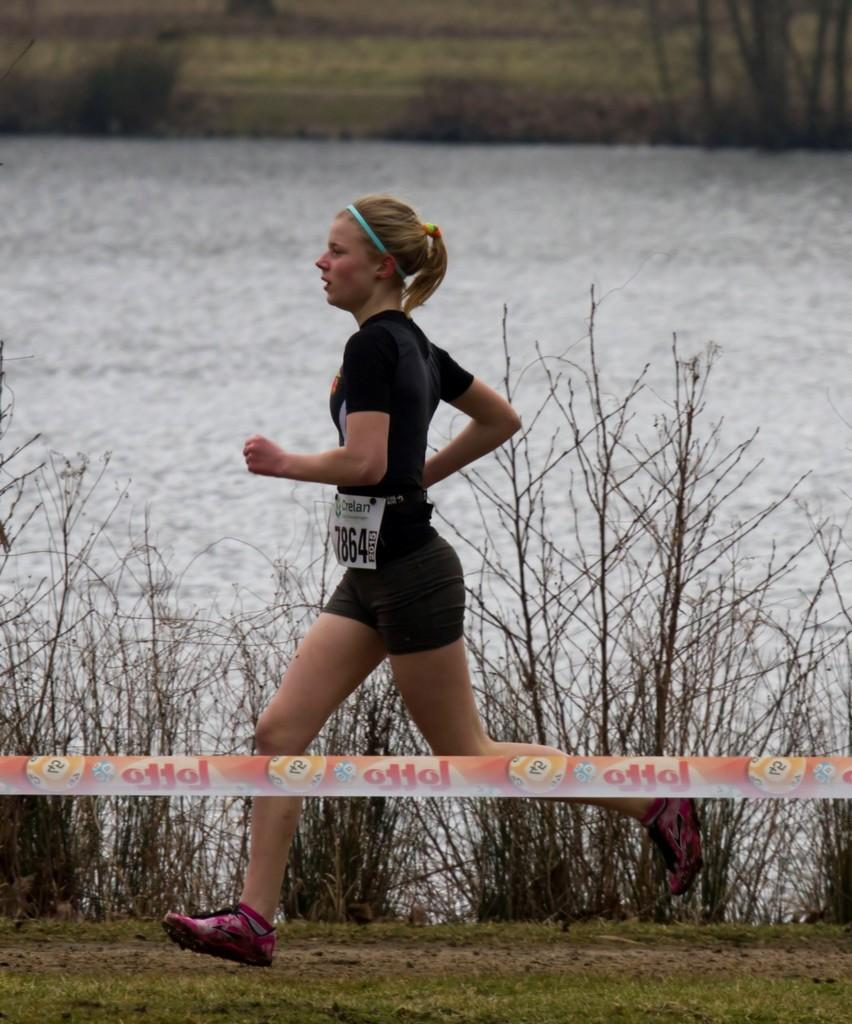What is the person in the image doing? There is a person running in the image. What is the person wearing while running? The person is wearing a black dress. What type of vegetation can be seen in the image? There are dry trees visible in the image. What natural element is present in the image? There is water visible in the image. What part of the plot can be seen in the image? There is no plot present in the image, as it is a photograph and not a story. 